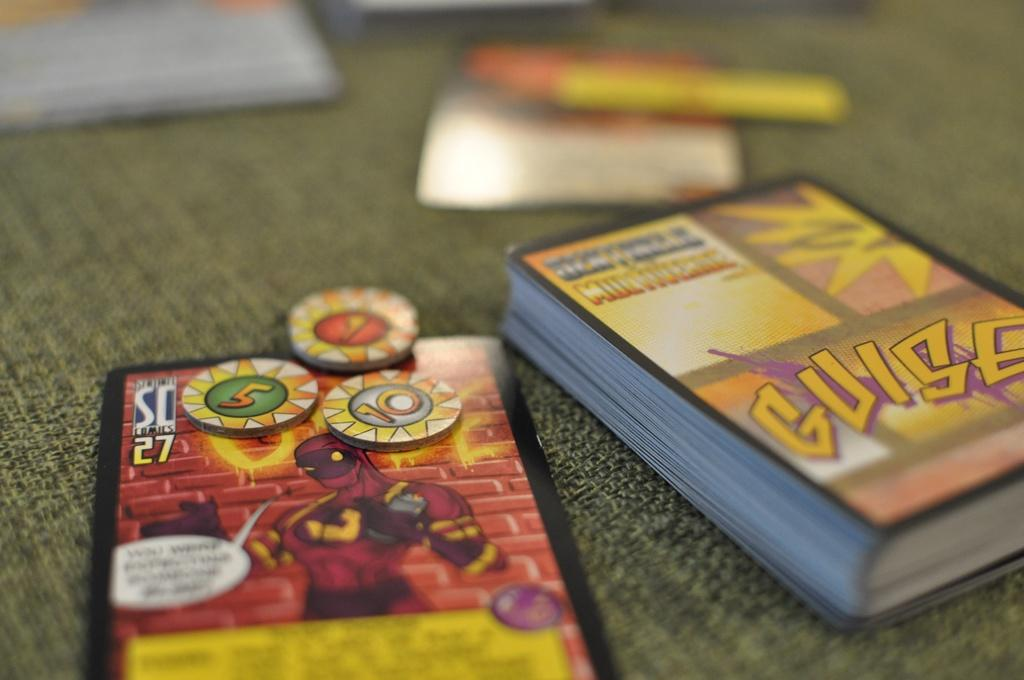<image>
Give a short and clear explanation of the subsequent image. A deck of Guise playing cards are on a table next to a care with three poker chips on it. 